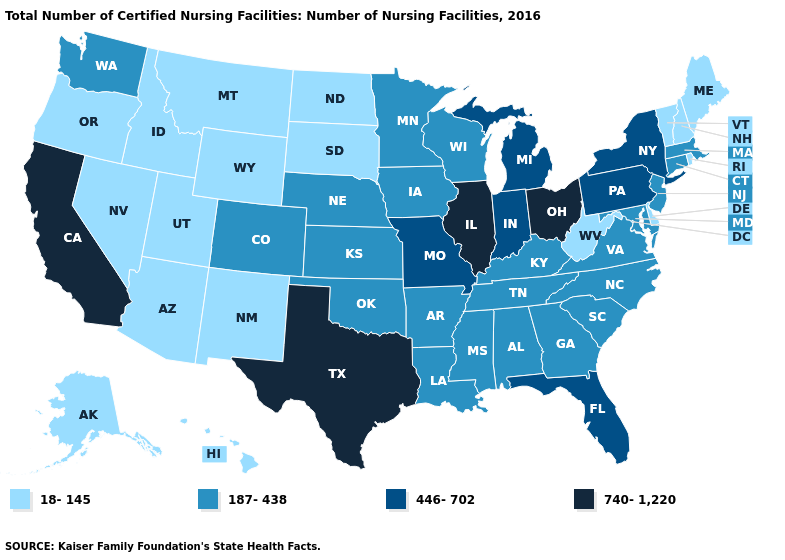Does California have the highest value in the West?
Write a very short answer. Yes. What is the value of Maine?
Answer briefly. 18-145. Name the states that have a value in the range 187-438?
Quick response, please. Alabama, Arkansas, Colorado, Connecticut, Georgia, Iowa, Kansas, Kentucky, Louisiana, Maryland, Massachusetts, Minnesota, Mississippi, Nebraska, New Jersey, North Carolina, Oklahoma, South Carolina, Tennessee, Virginia, Washington, Wisconsin. Does Delaware have a higher value than North Carolina?
Concise answer only. No. Is the legend a continuous bar?
Concise answer only. No. Which states have the highest value in the USA?
Answer briefly. California, Illinois, Ohio, Texas. What is the value of Virginia?
Be succinct. 187-438. What is the value of Wisconsin?
Be succinct. 187-438. Name the states that have a value in the range 740-1,220?
Quick response, please. California, Illinois, Ohio, Texas. What is the value of Louisiana?
Keep it brief. 187-438. Does Vermont have the lowest value in the USA?
Short answer required. Yes. Does Minnesota have the lowest value in the USA?
Quick response, please. No. Does Missouri have the highest value in the USA?
Give a very brief answer. No. Does Alaska have a lower value than Texas?
Keep it brief. Yes. What is the highest value in the South ?
Concise answer only. 740-1,220. 